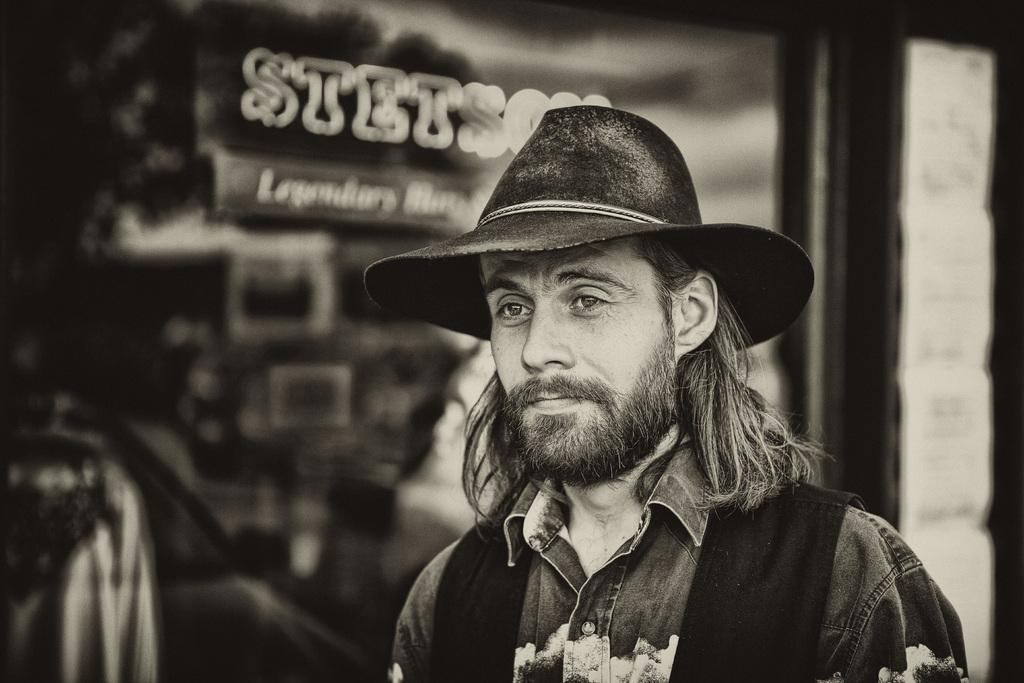What is the color scheme of the image? The image is black and white. What can be seen in the foreground of the image? There is a man standing in the image. What is the man wearing on his head? The man is wearing a hat. What is the man wearing on his upper body? The man is wearing a shirt. What is visible in the background of the image? There is a glass door in the background of the image. What is written or displayed on the glass door? There is a name on the glass door. How many birds are perched on the man's shoulder in the image? There are no birds present in the image; the man is standing alone. What is the man's wealth status based on the image? The image does not provide any information about the man's wealth status. 